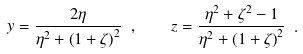<formula> <loc_0><loc_0><loc_500><loc_500>y = \frac { 2 \eta } { \eta ^ { 2 } + \left ( 1 + \zeta \right ) ^ { 2 } } \ , \quad z = \frac { \eta ^ { 2 } + \zeta ^ { 2 } - 1 } { \eta ^ { 2 } + \left ( 1 + \zeta \right ) ^ { 2 } } \ .</formula> 